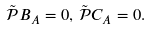Convert formula to latex. <formula><loc_0><loc_0><loc_500><loc_500>\tilde { \mathcal { P } } B _ { A } = 0 , \, \tilde { \mathcal { P } } C _ { A } = 0 .</formula> 